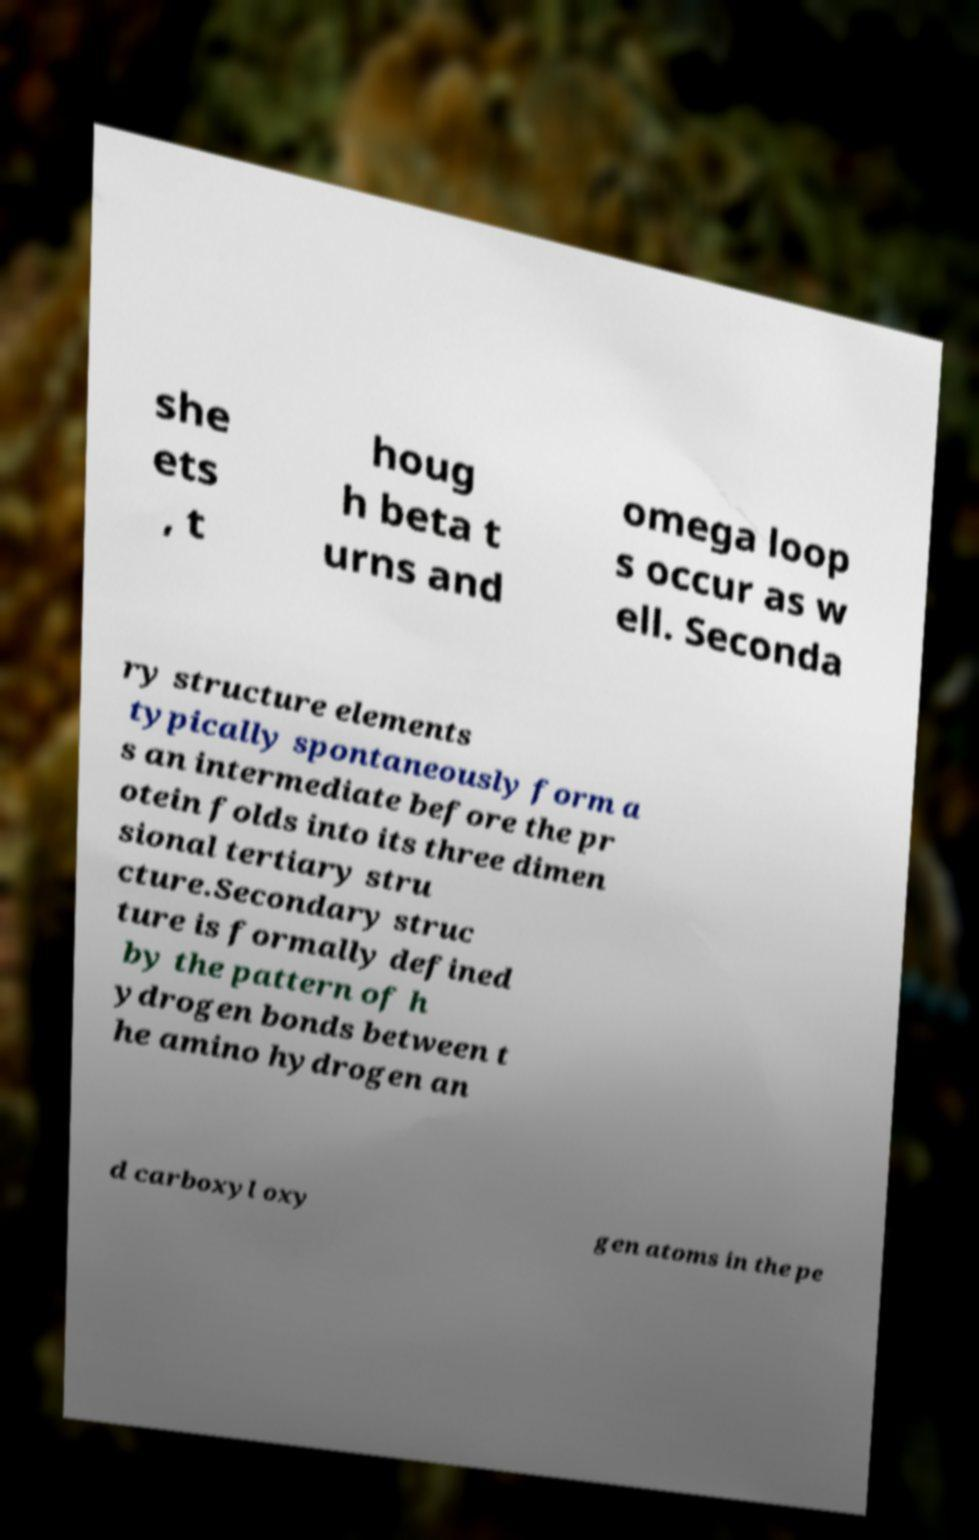What messages or text are displayed in this image? I need them in a readable, typed format. she ets , t houg h beta t urns and omega loop s occur as w ell. Seconda ry structure elements typically spontaneously form a s an intermediate before the pr otein folds into its three dimen sional tertiary stru cture.Secondary struc ture is formally defined by the pattern of h ydrogen bonds between t he amino hydrogen an d carboxyl oxy gen atoms in the pe 